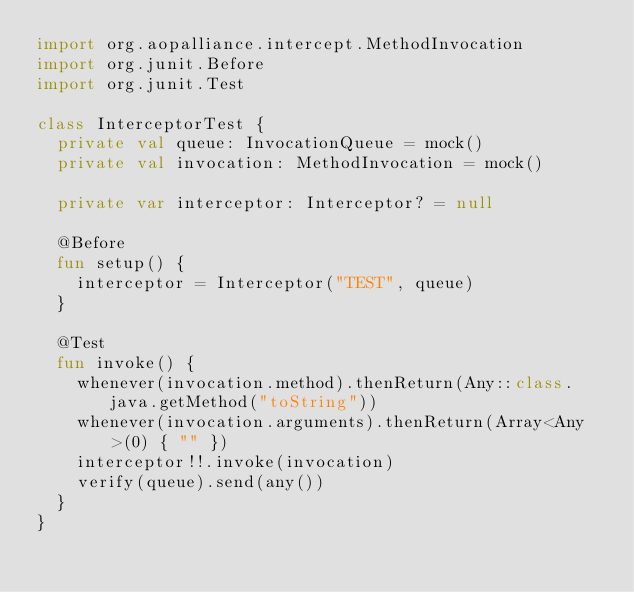<code> <loc_0><loc_0><loc_500><loc_500><_Kotlin_>import org.aopalliance.intercept.MethodInvocation
import org.junit.Before
import org.junit.Test

class InterceptorTest {
	private val queue: InvocationQueue = mock()
	private val invocation: MethodInvocation = mock()

	private var interceptor: Interceptor? = null

	@Before
	fun setup() {
		interceptor = Interceptor("TEST", queue)
	}

	@Test
	fun invoke() {
		whenever(invocation.method).thenReturn(Any::class.java.getMethod("toString"))
		whenever(invocation.arguments).thenReturn(Array<Any>(0) { "" })
		interceptor!!.invoke(invocation)
		verify(queue).send(any())
	}
}</code> 